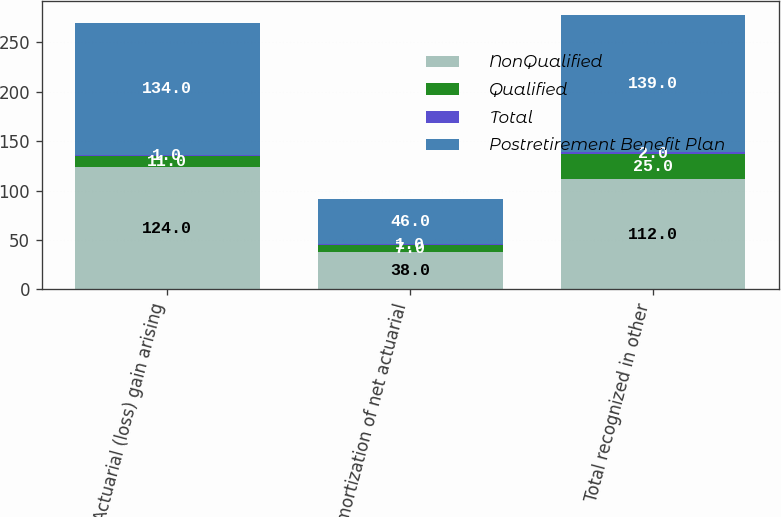<chart> <loc_0><loc_0><loc_500><loc_500><stacked_bar_chart><ecel><fcel>Actuarial (loss) gain arising<fcel>Amortization of net actuarial<fcel>Total recognized in other<nl><fcel>NonQualified<fcel>124<fcel>38<fcel>112<nl><fcel>Qualified<fcel>11<fcel>7<fcel>25<nl><fcel>Total<fcel>1<fcel>1<fcel>2<nl><fcel>Postretirement Benefit Plan<fcel>134<fcel>46<fcel>139<nl></chart> 